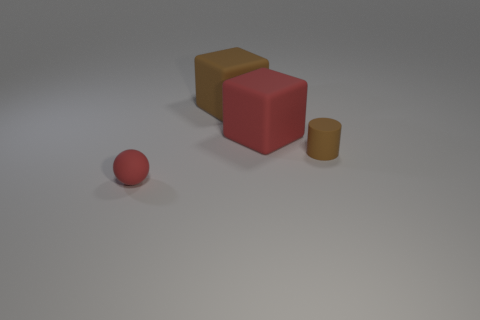What material is the red thing that is the same shape as the large brown rubber thing?
Your answer should be compact. Rubber. There is a matte object that is in front of the brown cylinder; is its color the same as the tiny rubber thing that is to the right of the big red rubber thing?
Offer a very short reply. No. What is the shape of the small red object?
Keep it short and to the point. Sphere. Is the number of red matte objects to the left of the red cube greater than the number of tiny brown metal balls?
Give a very brief answer. Yes. What shape is the red object that is right of the large brown matte block?
Give a very brief answer. Cube. How many other objects are the same shape as the tiny brown object?
Your answer should be compact. 0. Is the material of the large red cube that is in front of the brown rubber cube the same as the small red sphere?
Keep it short and to the point. Yes. Are there an equal number of tiny matte cylinders to the left of the large red object and large brown things that are behind the tiny ball?
Keep it short and to the point. No. There is a brown rubber cube behind the tiny red object; how big is it?
Provide a short and direct response. Large. Is there a object made of the same material as the sphere?
Give a very brief answer. Yes. 